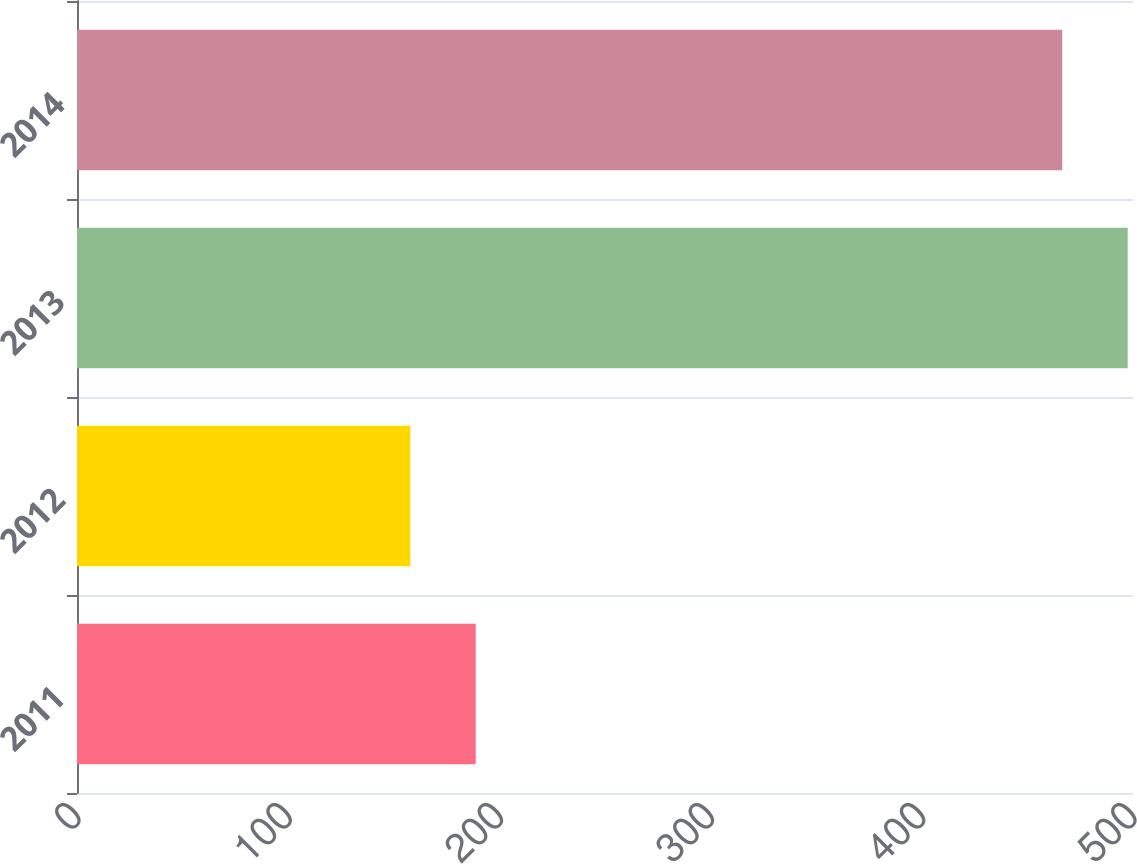Convert chart to OTSL. <chart><loc_0><loc_0><loc_500><loc_500><bar_chart><fcel>2011<fcel>2012<fcel>2013<fcel>2014<nl><fcel>188.79<fcel>157.8<fcel>497.49<fcel>466.5<nl></chart> 